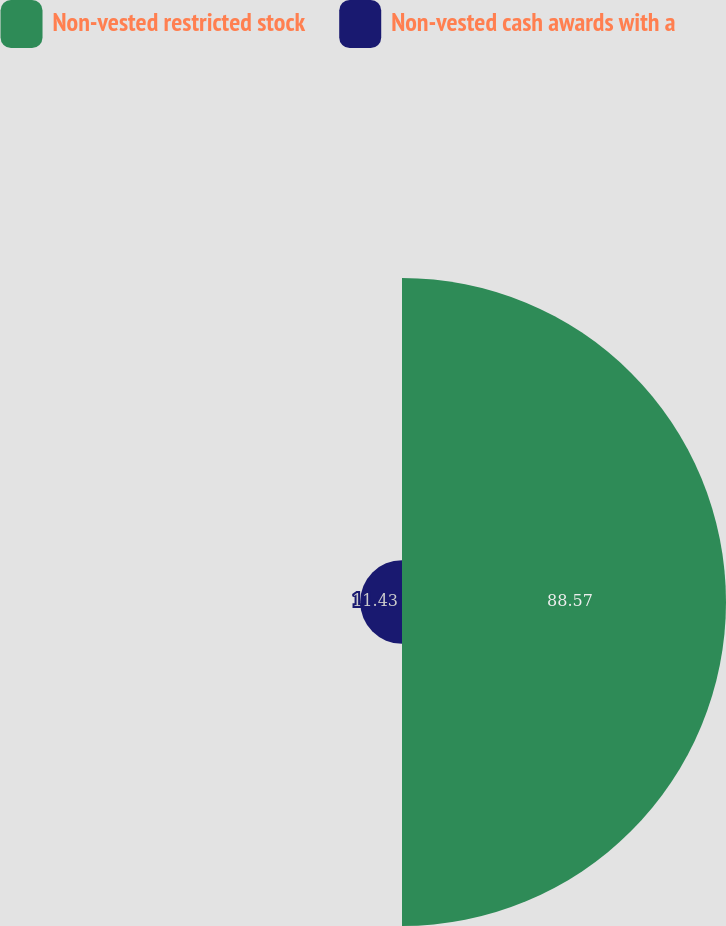<chart> <loc_0><loc_0><loc_500><loc_500><pie_chart><fcel>Non-vested restricted stock<fcel>Non-vested cash awards with a<nl><fcel>88.57%<fcel>11.43%<nl></chart> 